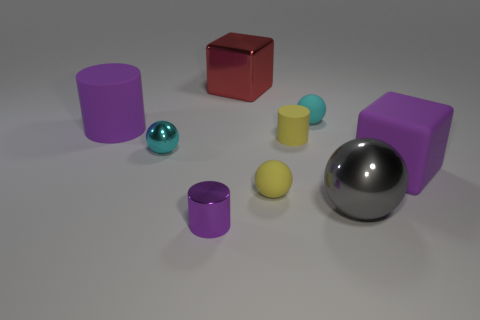Add 1 tiny yellow cylinders. How many objects exist? 10 Subtract all purple balls. Subtract all blue blocks. How many balls are left? 4 Subtract all blocks. How many objects are left? 7 Add 1 tiny yellow objects. How many tiny yellow objects exist? 3 Subtract 1 yellow cylinders. How many objects are left? 8 Subtract all shiny spheres. Subtract all tiny metallic spheres. How many objects are left? 6 Add 1 cyan things. How many cyan things are left? 3 